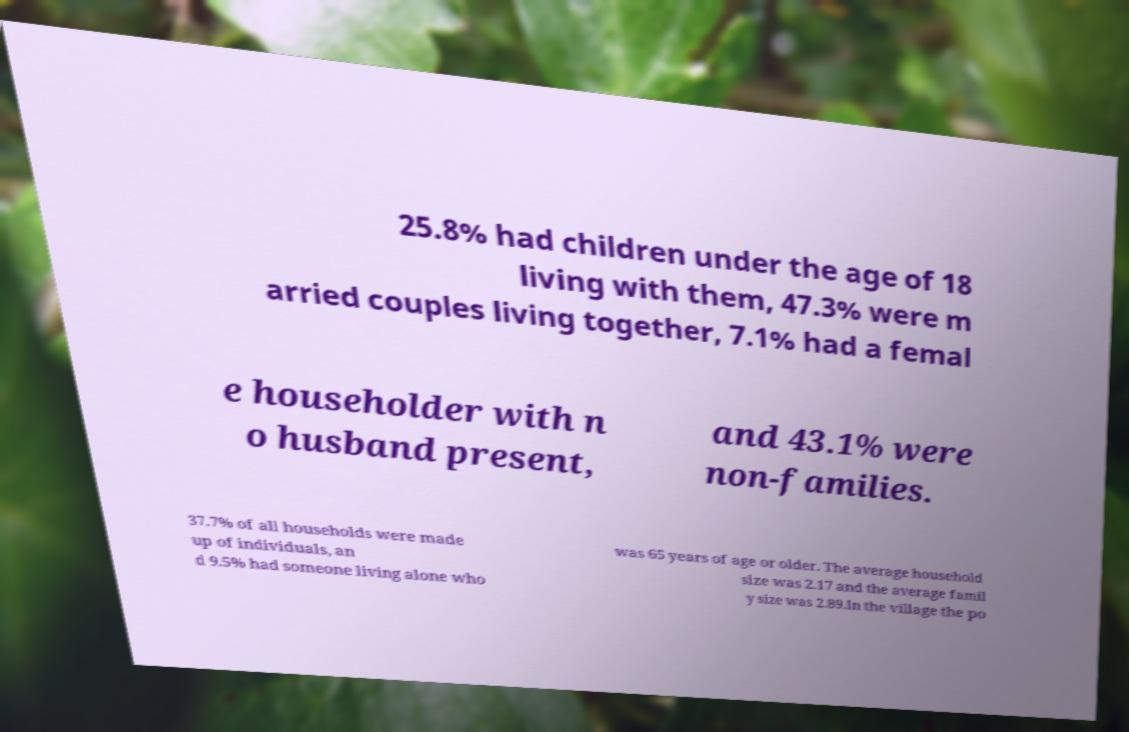I need the written content from this picture converted into text. Can you do that? 25.8% had children under the age of 18 living with them, 47.3% were m arried couples living together, 7.1% had a femal e householder with n o husband present, and 43.1% were non-families. 37.7% of all households were made up of individuals, an d 9.5% had someone living alone who was 65 years of age or older. The average household size was 2.17 and the average famil y size was 2.89.In the village the po 